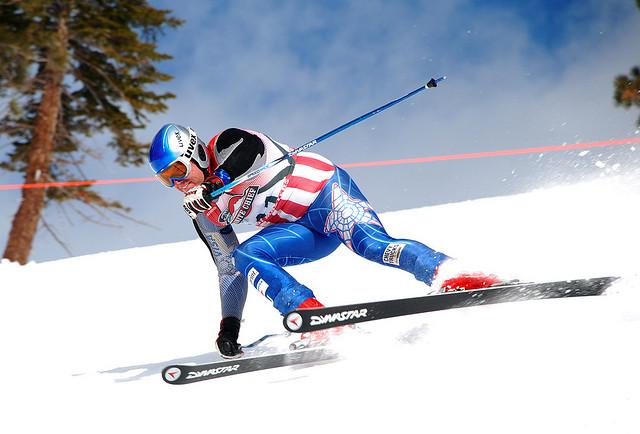What sport is this person participating in?
Short answer required. Skiing. What type of clothing the person is wearing?
Write a very short answer. Ski. Is this at the beach?
Short answer required. No. 